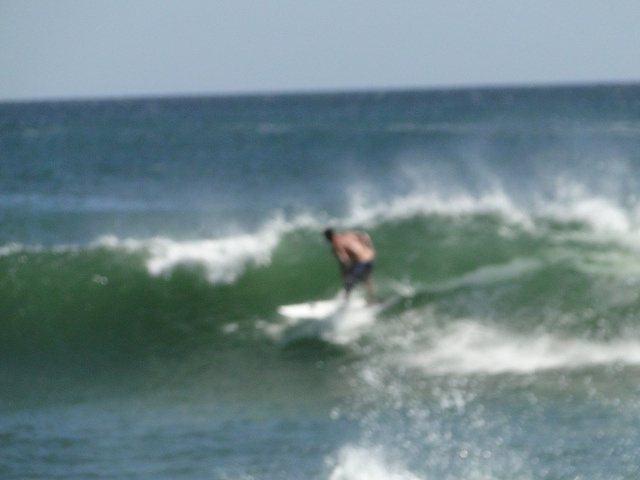Describe the objects in this image and their specific colors. I can see people in darkgray, gray, and black tones and surfboard in darkgray, lightgray, and gray tones in this image. 